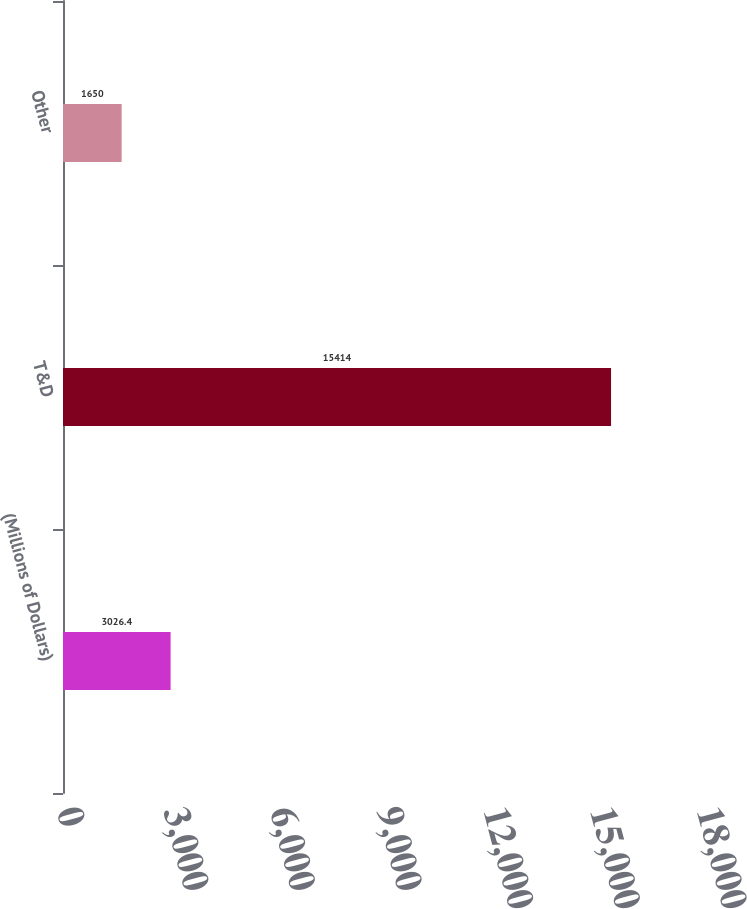<chart> <loc_0><loc_0><loc_500><loc_500><bar_chart><fcel>(Millions of Dollars)<fcel>T&D<fcel>Other<nl><fcel>3026.4<fcel>15414<fcel>1650<nl></chart> 